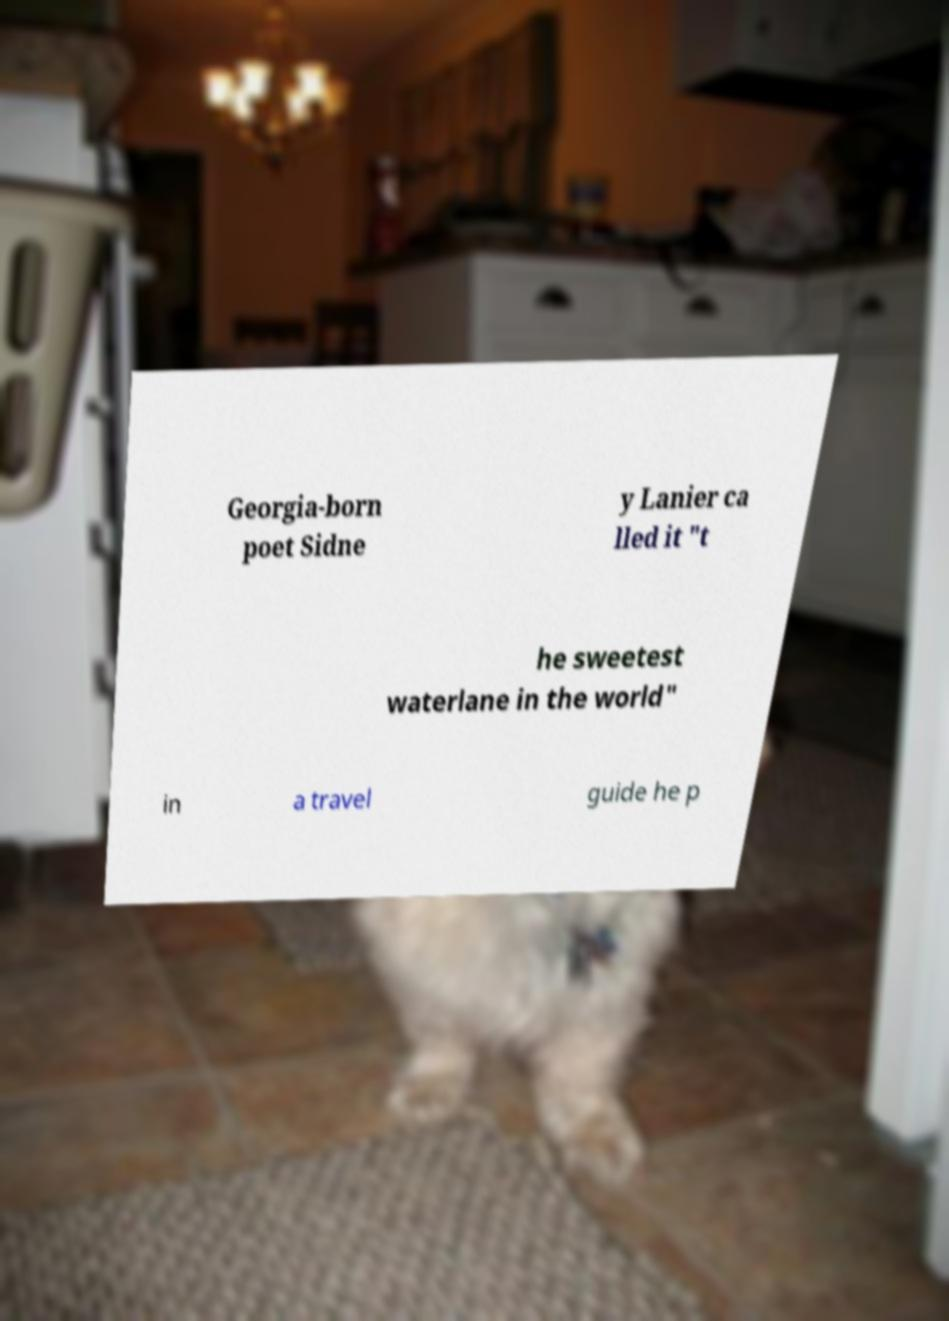Could you assist in decoding the text presented in this image and type it out clearly? Georgia-born poet Sidne y Lanier ca lled it "t he sweetest waterlane in the world" in a travel guide he p 